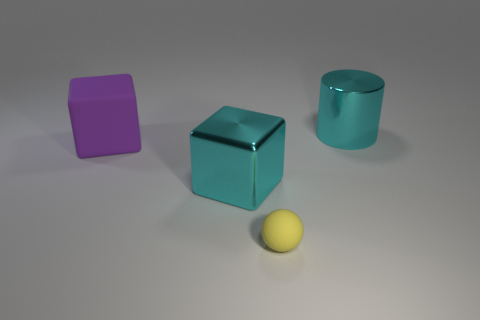Add 2 big cubes. How many objects exist? 6 Subtract all spheres. How many objects are left? 3 Subtract 0 purple balls. How many objects are left? 4 Subtract all cyan metallic cubes. Subtract all spheres. How many objects are left? 2 Add 1 large matte cubes. How many large matte cubes are left? 2 Add 4 big purple matte things. How many big purple matte things exist? 5 